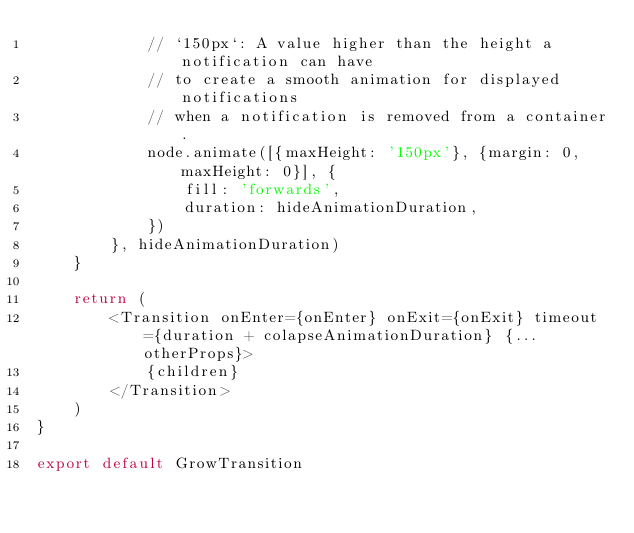<code> <loc_0><loc_0><loc_500><loc_500><_TypeScript_>            // `150px`: A value higher than the height a notification can have
            // to create a smooth animation for displayed notifications
            // when a notification is removed from a container.
            node.animate([{maxHeight: '150px'}, {margin: 0, maxHeight: 0}], {
                fill: 'forwards',
                duration: hideAnimationDuration,
            })
        }, hideAnimationDuration)
    }

    return (
        <Transition onEnter={onEnter} onExit={onExit} timeout={duration + colapseAnimationDuration} {...otherProps}>
            {children}
        </Transition>
    )
}

export default GrowTransition
</code> 